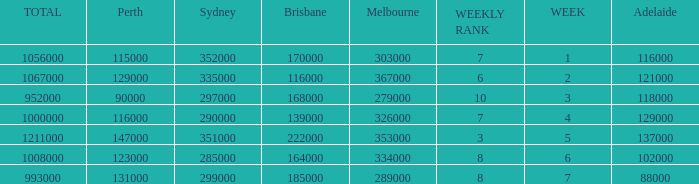How many Adelaide viewers were there in Week 5? 137000.0. 